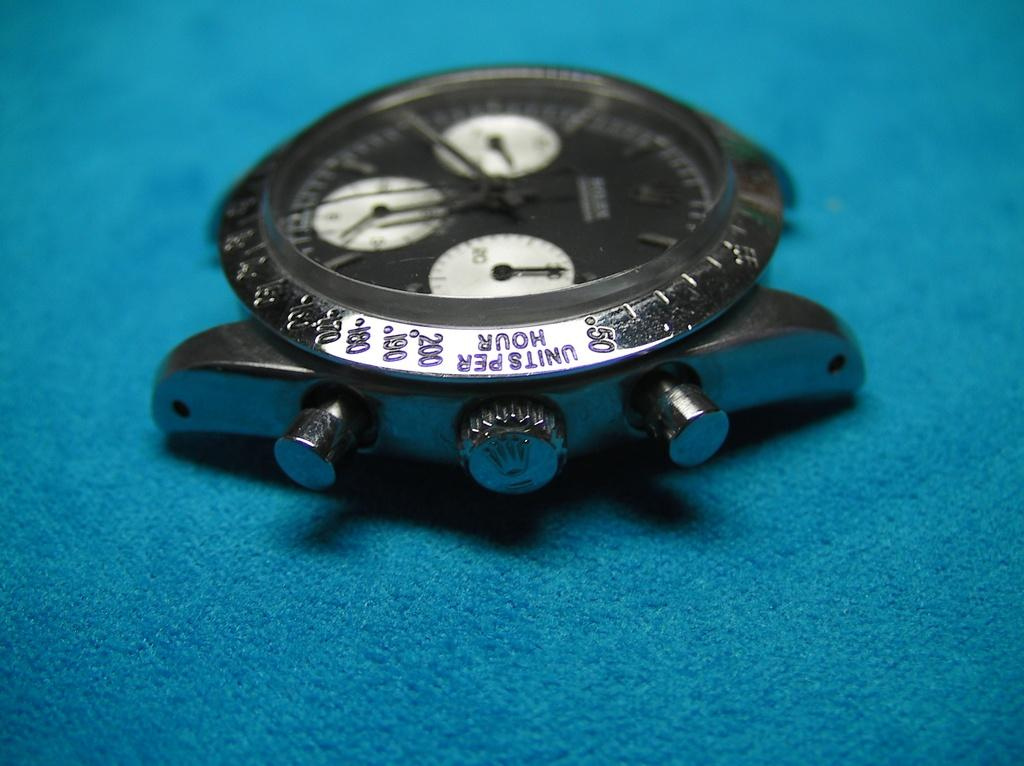<image>
Give a short and clear explanation of the subsequent image. A strapless wristwatch with the words Units per Hour above the twist dial. 